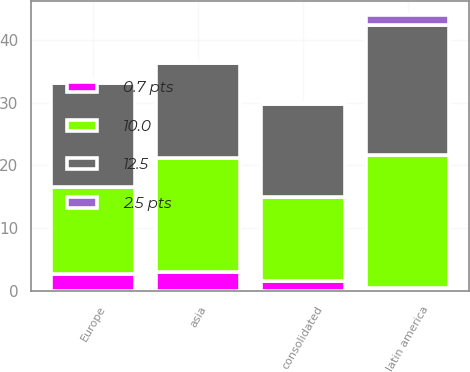Convert chart to OTSL. <chart><loc_0><loc_0><loc_500><loc_500><stacked_bar_chart><ecel><fcel>Europe<fcel>latin america<fcel>asia<fcel>consolidated<nl><fcel>10.0<fcel>14<fcel>21.2<fcel>18.2<fcel>13.3<nl><fcel>0.7 pts<fcel>2.6<fcel>0.4<fcel>3<fcel>1.6<nl><fcel>12.5<fcel>16.6<fcel>20.8<fcel>15.2<fcel>14.9<nl><fcel>2.5 pts<fcel>0.4<fcel>1.6<fcel>0.1<fcel>0.2<nl></chart> 